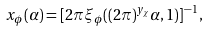<formula> <loc_0><loc_0><loc_500><loc_500>x _ { \phi } ( \alpha ) = [ 2 \pi \xi _ { \phi } ( ( 2 \pi ) ^ { y _ { \chi } } \alpha , 1 ) ] ^ { - 1 } \, ,</formula> 